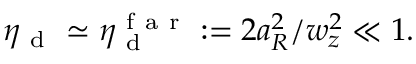<formula> <loc_0><loc_0><loc_500><loc_500>\eta _ { d } \simeq \eta _ { d } ^ { f a r } \colon = 2 a _ { R } ^ { 2 } / w _ { z } ^ { 2 } \ll 1 .</formula> 